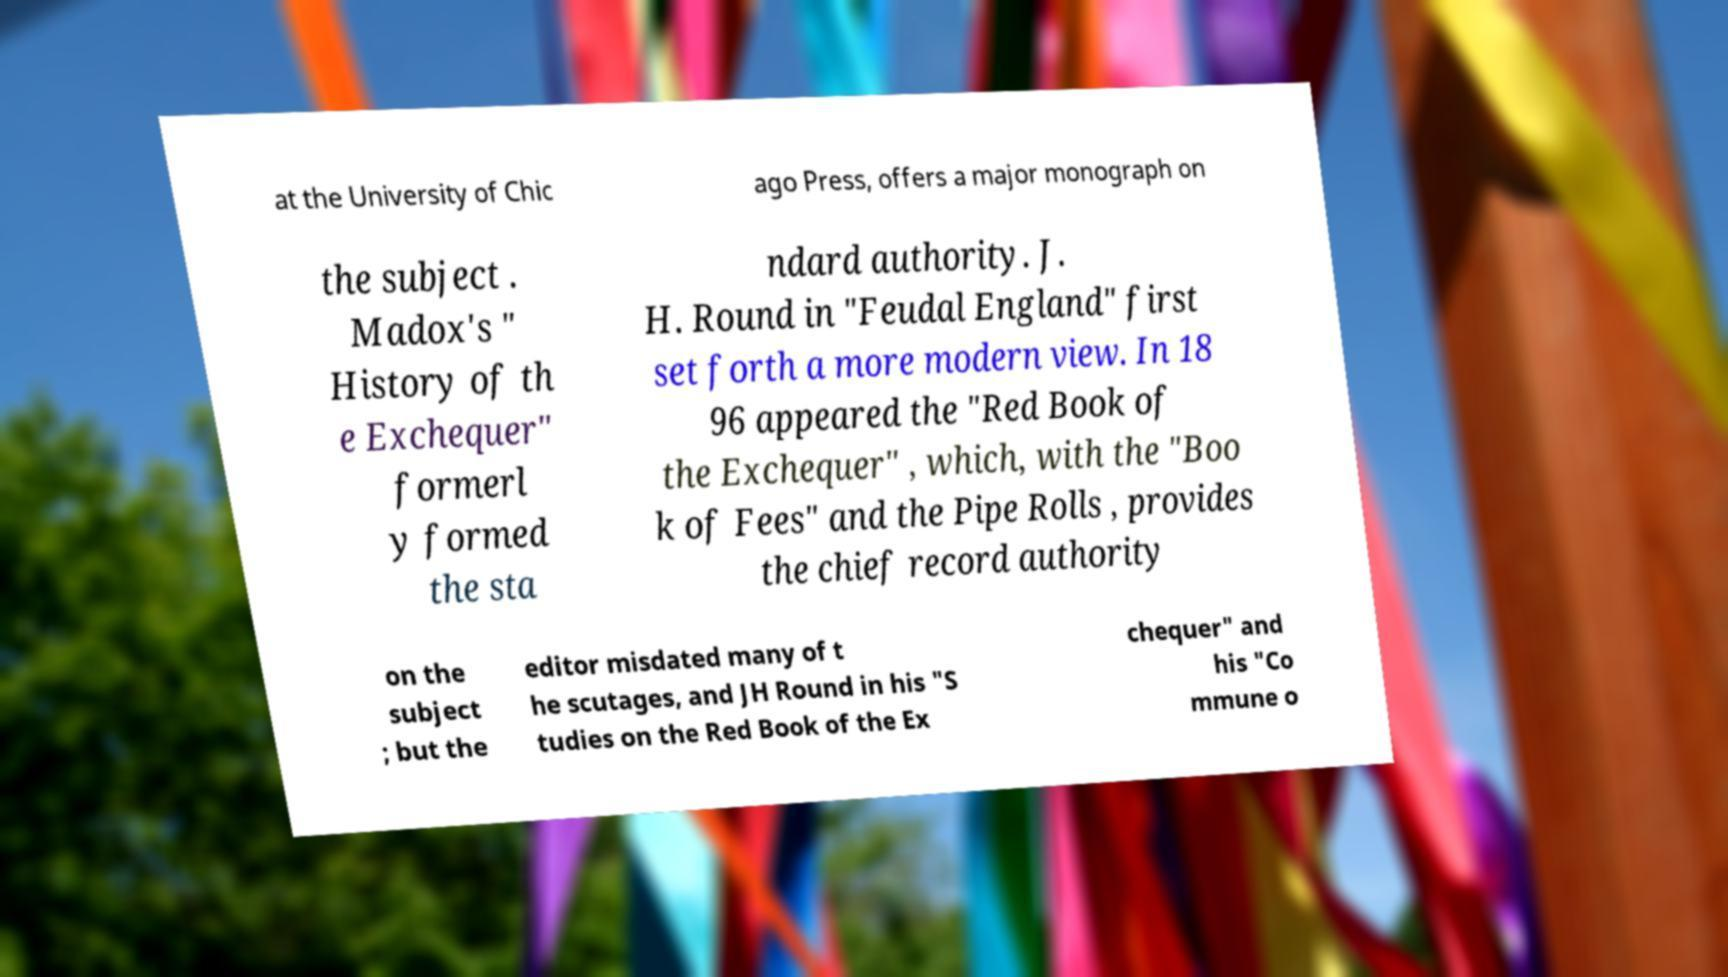Please identify and transcribe the text found in this image. at the University of Chic ago Press, offers a major monograph on the subject . Madox's " History of th e Exchequer" formerl y formed the sta ndard authority. J. H. Round in "Feudal England" first set forth a more modern view. In 18 96 appeared the "Red Book of the Exchequer" , which, with the "Boo k of Fees" and the Pipe Rolls , provides the chief record authority on the subject ; but the editor misdated many of t he scutages, and JH Round in his "S tudies on the Red Book of the Ex chequer" and his "Co mmune o 